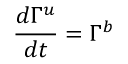<formula> <loc_0><loc_0><loc_500><loc_500>\frac { d \Gamma ^ { u } } { d t } = \Gamma ^ { b }</formula> 